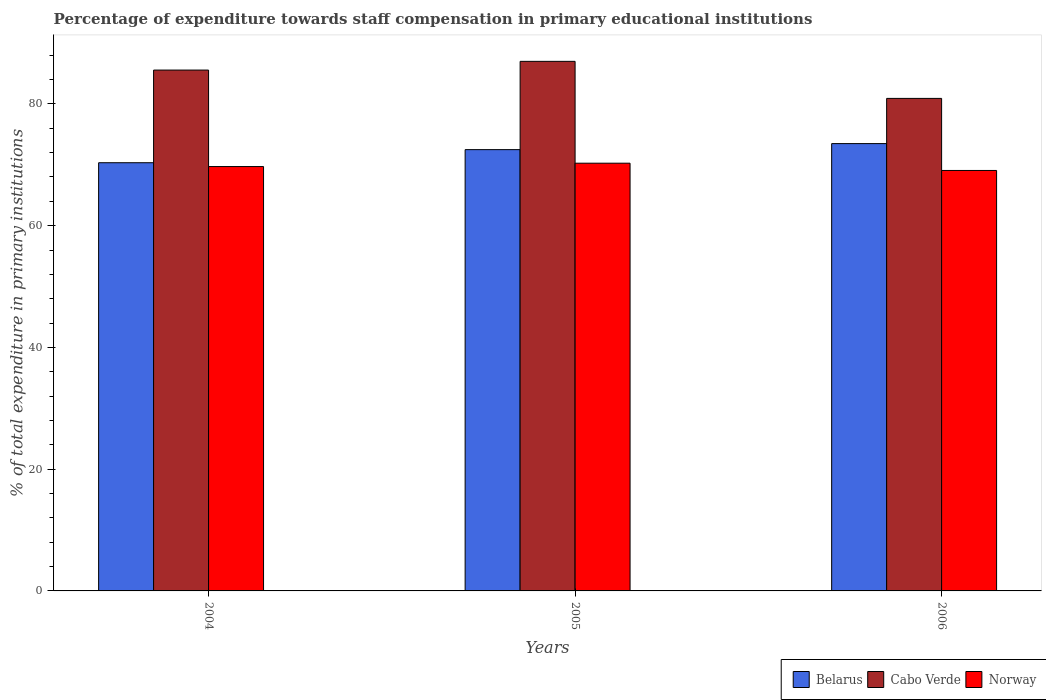How many different coloured bars are there?
Provide a succinct answer. 3. How many groups of bars are there?
Offer a very short reply. 3. Are the number of bars per tick equal to the number of legend labels?
Give a very brief answer. Yes. Are the number of bars on each tick of the X-axis equal?
Your response must be concise. Yes. How many bars are there on the 1st tick from the right?
Your response must be concise. 3. What is the label of the 2nd group of bars from the left?
Your answer should be compact. 2005. In how many cases, is the number of bars for a given year not equal to the number of legend labels?
Your response must be concise. 0. What is the percentage of expenditure towards staff compensation in Belarus in 2005?
Ensure brevity in your answer.  72.49. Across all years, what is the maximum percentage of expenditure towards staff compensation in Belarus?
Offer a terse response. 73.49. Across all years, what is the minimum percentage of expenditure towards staff compensation in Cabo Verde?
Provide a succinct answer. 80.91. What is the total percentage of expenditure towards staff compensation in Norway in the graph?
Make the answer very short. 209.05. What is the difference between the percentage of expenditure towards staff compensation in Cabo Verde in 2005 and that in 2006?
Keep it short and to the point. 6.09. What is the difference between the percentage of expenditure towards staff compensation in Cabo Verde in 2005 and the percentage of expenditure towards staff compensation in Belarus in 2004?
Keep it short and to the point. 16.65. What is the average percentage of expenditure towards staff compensation in Belarus per year?
Your response must be concise. 72.11. In the year 2006, what is the difference between the percentage of expenditure towards staff compensation in Norway and percentage of expenditure towards staff compensation in Belarus?
Keep it short and to the point. -4.41. In how many years, is the percentage of expenditure towards staff compensation in Norway greater than 40 %?
Your answer should be compact. 3. What is the ratio of the percentage of expenditure towards staff compensation in Cabo Verde in 2004 to that in 2006?
Provide a short and direct response. 1.06. Is the percentage of expenditure towards staff compensation in Cabo Verde in 2004 less than that in 2006?
Offer a terse response. No. Is the difference between the percentage of expenditure towards staff compensation in Norway in 2004 and 2006 greater than the difference between the percentage of expenditure towards staff compensation in Belarus in 2004 and 2006?
Your response must be concise. Yes. What is the difference between the highest and the second highest percentage of expenditure towards staff compensation in Norway?
Offer a terse response. 0.55. What is the difference between the highest and the lowest percentage of expenditure towards staff compensation in Cabo Verde?
Make the answer very short. 6.09. Is the sum of the percentage of expenditure towards staff compensation in Belarus in 2004 and 2006 greater than the maximum percentage of expenditure towards staff compensation in Norway across all years?
Your answer should be very brief. Yes. What does the 3rd bar from the left in 2004 represents?
Keep it short and to the point. Norway. What does the 1st bar from the right in 2005 represents?
Offer a very short reply. Norway. Is it the case that in every year, the sum of the percentage of expenditure towards staff compensation in Cabo Verde and percentage of expenditure towards staff compensation in Norway is greater than the percentage of expenditure towards staff compensation in Belarus?
Offer a terse response. Yes. How many years are there in the graph?
Offer a terse response. 3. Are the values on the major ticks of Y-axis written in scientific E-notation?
Offer a very short reply. No. Where does the legend appear in the graph?
Your answer should be very brief. Bottom right. How are the legend labels stacked?
Provide a succinct answer. Horizontal. What is the title of the graph?
Give a very brief answer. Percentage of expenditure towards staff compensation in primary educational institutions. Does "East Asia (developing only)" appear as one of the legend labels in the graph?
Your answer should be compact. No. What is the label or title of the Y-axis?
Give a very brief answer. % of total expenditure in primary institutions. What is the % of total expenditure in primary institutions in Belarus in 2004?
Provide a succinct answer. 70.34. What is the % of total expenditure in primary institutions in Cabo Verde in 2004?
Offer a terse response. 85.57. What is the % of total expenditure in primary institutions of Norway in 2004?
Offer a very short reply. 69.71. What is the % of total expenditure in primary institutions of Belarus in 2005?
Make the answer very short. 72.49. What is the % of total expenditure in primary institutions of Cabo Verde in 2005?
Give a very brief answer. 87. What is the % of total expenditure in primary institutions of Norway in 2005?
Provide a succinct answer. 70.27. What is the % of total expenditure in primary institutions in Belarus in 2006?
Offer a terse response. 73.49. What is the % of total expenditure in primary institutions of Cabo Verde in 2006?
Make the answer very short. 80.91. What is the % of total expenditure in primary institutions in Norway in 2006?
Your answer should be very brief. 69.07. Across all years, what is the maximum % of total expenditure in primary institutions of Belarus?
Give a very brief answer. 73.49. Across all years, what is the maximum % of total expenditure in primary institutions of Cabo Verde?
Provide a succinct answer. 87. Across all years, what is the maximum % of total expenditure in primary institutions of Norway?
Offer a terse response. 70.27. Across all years, what is the minimum % of total expenditure in primary institutions of Belarus?
Give a very brief answer. 70.34. Across all years, what is the minimum % of total expenditure in primary institutions of Cabo Verde?
Your answer should be very brief. 80.91. Across all years, what is the minimum % of total expenditure in primary institutions of Norway?
Offer a very short reply. 69.07. What is the total % of total expenditure in primary institutions in Belarus in the graph?
Provide a succinct answer. 216.32. What is the total % of total expenditure in primary institutions of Cabo Verde in the graph?
Provide a short and direct response. 253.48. What is the total % of total expenditure in primary institutions of Norway in the graph?
Provide a succinct answer. 209.05. What is the difference between the % of total expenditure in primary institutions in Belarus in 2004 and that in 2005?
Provide a short and direct response. -2.15. What is the difference between the % of total expenditure in primary institutions of Cabo Verde in 2004 and that in 2005?
Ensure brevity in your answer.  -1.43. What is the difference between the % of total expenditure in primary institutions in Norway in 2004 and that in 2005?
Ensure brevity in your answer.  -0.55. What is the difference between the % of total expenditure in primary institutions of Belarus in 2004 and that in 2006?
Give a very brief answer. -3.14. What is the difference between the % of total expenditure in primary institutions in Cabo Verde in 2004 and that in 2006?
Make the answer very short. 4.65. What is the difference between the % of total expenditure in primary institutions of Norway in 2004 and that in 2006?
Make the answer very short. 0.64. What is the difference between the % of total expenditure in primary institutions in Belarus in 2005 and that in 2006?
Give a very brief answer. -0.99. What is the difference between the % of total expenditure in primary institutions in Cabo Verde in 2005 and that in 2006?
Your response must be concise. 6.09. What is the difference between the % of total expenditure in primary institutions in Norway in 2005 and that in 2006?
Offer a very short reply. 1.19. What is the difference between the % of total expenditure in primary institutions of Belarus in 2004 and the % of total expenditure in primary institutions of Cabo Verde in 2005?
Ensure brevity in your answer.  -16.65. What is the difference between the % of total expenditure in primary institutions of Belarus in 2004 and the % of total expenditure in primary institutions of Norway in 2005?
Make the answer very short. 0.08. What is the difference between the % of total expenditure in primary institutions of Cabo Verde in 2004 and the % of total expenditure in primary institutions of Norway in 2005?
Offer a terse response. 15.3. What is the difference between the % of total expenditure in primary institutions of Belarus in 2004 and the % of total expenditure in primary institutions of Cabo Verde in 2006?
Make the answer very short. -10.57. What is the difference between the % of total expenditure in primary institutions in Belarus in 2004 and the % of total expenditure in primary institutions in Norway in 2006?
Keep it short and to the point. 1.27. What is the difference between the % of total expenditure in primary institutions of Cabo Verde in 2004 and the % of total expenditure in primary institutions of Norway in 2006?
Ensure brevity in your answer.  16.49. What is the difference between the % of total expenditure in primary institutions in Belarus in 2005 and the % of total expenditure in primary institutions in Cabo Verde in 2006?
Offer a terse response. -8.42. What is the difference between the % of total expenditure in primary institutions of Belarus in 2005 and the % of total expenditure in primary institutions of Norway in 2006?
Offer a terse response. 3.42. What is the difference between the % of total expenditure in primary institutions in Cabo Verde in 2005 and the % of total expenditure in primary institutions in Norway in 2006?
Ensure brevity in your answer.  17.92. What is the average % of total expenditure in primary institutions of Belarus per year?
Offer a very short reply. 72.11. What is the average % of total expenditure in primary institutions of Cabo Verde per year?
Give a very brief answer. 84.49. What is the average % of total expenditure in primary institutions of Norway per year?
Keep it short and to the point. 69.68. In the year 2004, what is the difference between the % of total expenditure in primary institutions of Belarus and % of total expenditure in primary institutions of Cabo Verde?
Your response must be concise. -15.22. In the year 2004, what is the difference between the % of total expenditure in primary institutions of Belarus and % of total expenditure in primary institutions of Norway?
Offer a very short reply. 0.63. In the year 2004, what is the difference between the % of total expenditure in primary institutions of Cabo Verde and % of total expenditure in primary institutions of Norway?
Ensure brevity in your answer.  15.85. In the year 2005, what is the difference between the % of total expenditure in primary institutions of Belarus and % of total expenditure in primary institutions of Cabo Verde?
Provide a short and direct response. -14.5. In the year 2005, what is the difference between the % of total expenditure in primary institutions in Belarus and % of total expenditure in primary institutions in Norway?
Keep it short and to the point. 2.23. In the year 2005, what is the difference between the % of total expenditure in primary institutions in Cabo Verde and % of total expenditure in primary institutions in Norway?
Offer a very short reply. 16.73. In the year 2006, what is the difference between the % of total expenditure in primary institutions of Belarus and % of total expenditure in primary institutions of Cabo Verde?
Your answer should be compact. -7.43. In the year 2006, what is the difference between the % of total expenditure in primary institutions of Belarus and % of total expenditure in primary institutions of Norway?
Offer a very short reply. 4.41. In the year 2006, what is the difference between the % of total expenditure in primary institutions in Cabo Verde and % of total expenditure in primary institutions in Norway?
Offer a very short reply. 11.84. What is the ratio of the % of total expenditure in primary institutions in Belarus in 2004 to that in 2005?
Offer a terse response. 0.97. What is the ratio of the % of total expenditure in primary institutions of Cabo Verde in 2004 to that in 2005?
Provide a short and direct response. 0.98. What is the ratio of the % of total expenditure in primary institutions of Norway in 2004 to that in 2005?
Provide a short and direct response. 0.99. What is the ratio of the % of total expenditure in primary institutions in Belarus in 2004 to that in 2006?
Offer a very short reply. 0.96. What is the ratio of the % of total expenditure in primary institutions of Cabo Verde in 2004 to that in 2006?
Provide a short and direct response. 1.06. What is the ratio of the % of total expenditure in primary institutions in Norway in 2004 to that in 2006?
Provide a short and direct response. 1.01. What is the ratio of the % of total expenditure in primary institutions in Belarus in 2005 to that in 2006?
Offer a very short reply. 0.99. What is the ratio of the % of total expenditure in primary institutions in Cabo Verde in 2005 to that in 2006?
Ensure brevity in your answer.  1.08. What is the ratio of the % of total expenditure in primary institutions in Norway in 2005 to that in 2006?
Offer a very short reply. 1.02. What is the difference between the highest and the second highest % of total expenditure in primary institutions in Belarus?
Keep it short and to the point. 0.99. What is the difference between the highest and the second highest % of total expenditure in primary institutions of Cabo Verde?
Provide a short and direct response. 1.43. What is the difference between the highest and the second highest % of total expenditure in primary institutions of Norway?
Offer a very short reply. 0.55. What is the difference between the highest and the lowest % of total expenditure in primary institutions in Belarus?
Your response must be concise. 3.14. What is the difference between the highest and the lowest % of total expenditure in primary institutions in Cabo Verde?
Your answer should be compact. 6.09. What is the difference between the highest and the lowest % of total expenditure in primary institutions in Norway?
Ensure brevity in your answer.  1.19. 